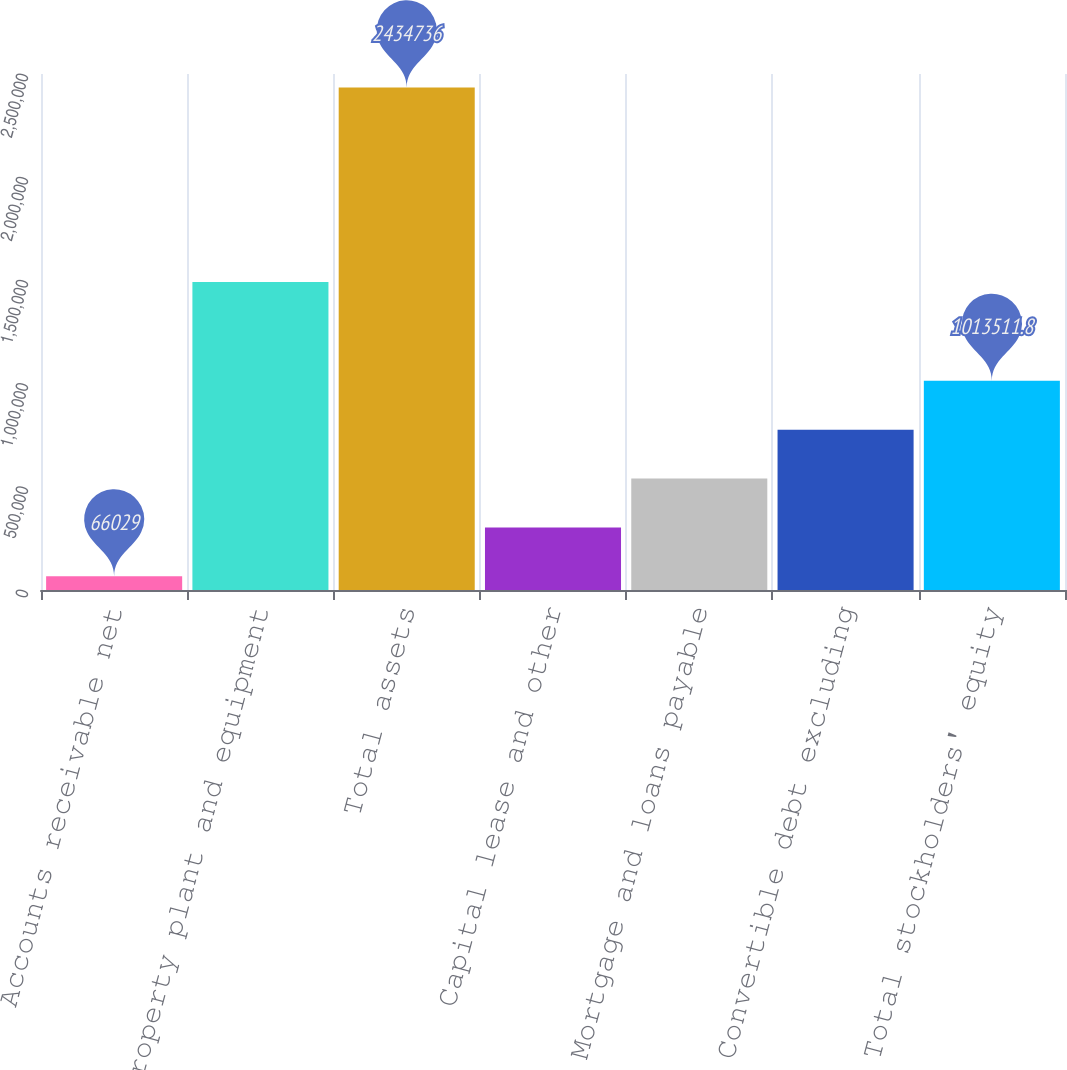Convert chart. <chart><loc_0><loc_0><loc_500><loc_500><bar_chart><fcel>Accounts receivable net<fcel>Property plant and equipment<fcel>Total assets<fcel>Capital lease and other<fcel>Mortgage and loans payable<fcel>Convertible debt excluding<fcel>Total stockholders' equity<nl><fcel>66029<fcel>1.49283e+06<fcel>2.43474e+06<fcel>302900<fcel>539770<fcel>776641<fcel>1.01351e+06<nl></chart> 